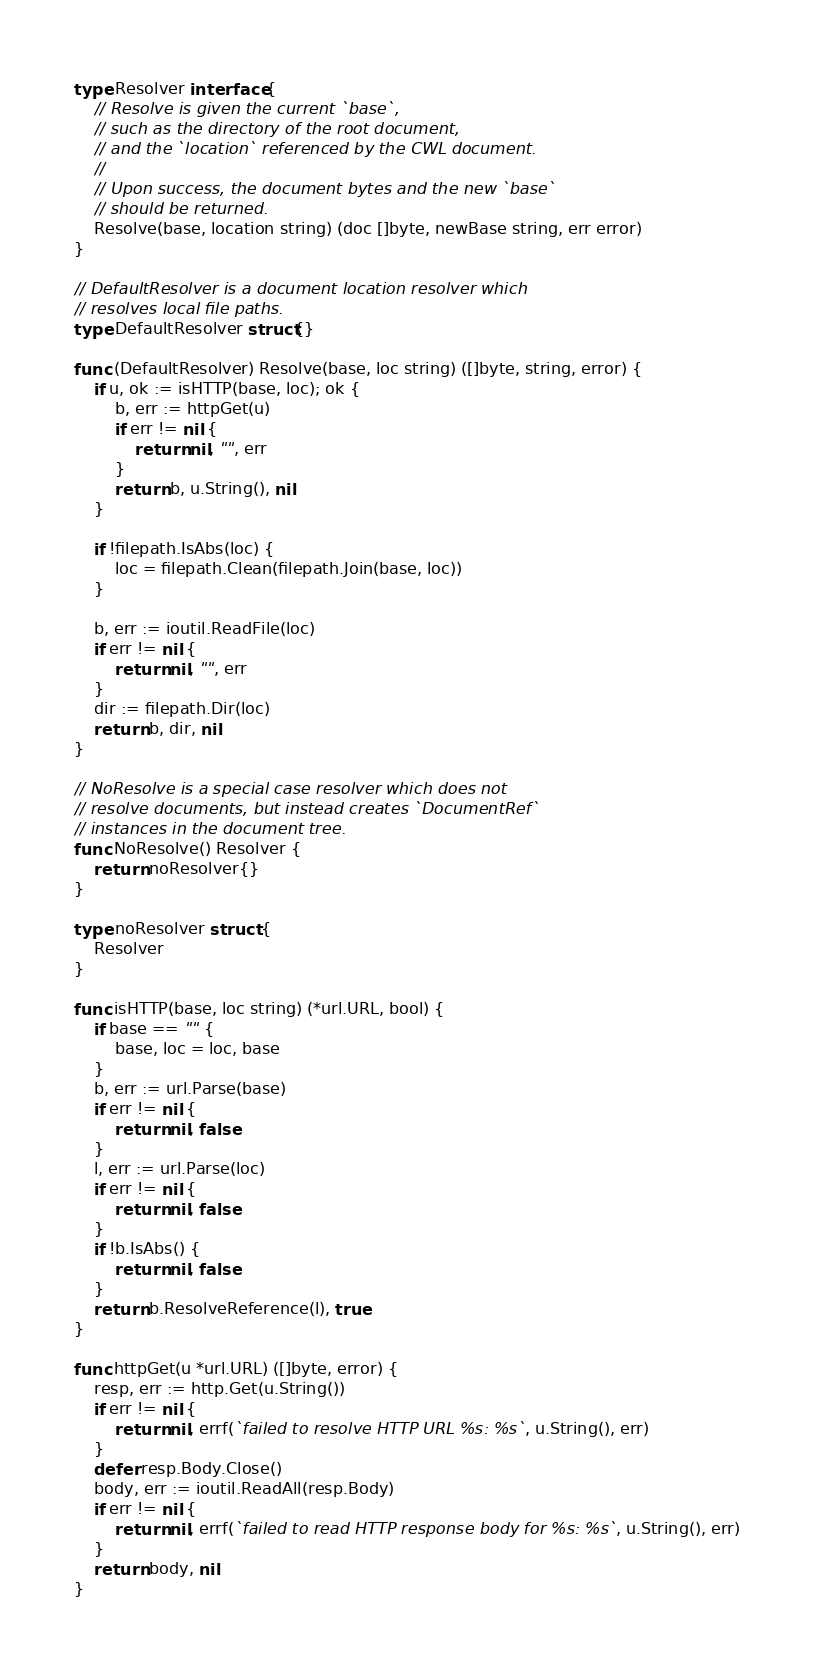<code> <loc_0><loc_0><loc_500><loc_500><_Go_>type Resolver interface {
	// Resolve is given the current `base`,
	// such as the directory of the root document,
	// and the `location` referenced by the CWL document.
	//
	// Upon success, the document bytes and the new `base`
	// should be returned.
	Resolve(base, location string) (doc []byte, newBase string, err error)
}

// DefaultResolver is a document location resolver which
// resolves local file paths.
type DefaultResolver struct{}

func (DefaultResolver) Resolve(base, loc string) ([]byte, string, error) {
	if u, ok := isHTTP(base, loc); ok {
		b, err := httpGet(u)
		if err != nil {
			return nil, "", err
		}
		return b, u.String(), nil
	}

	if !filepath.IsAbs(loc) {
		loc = filepath.Clean(filepath.Join(base, loc))
	}

	b, err := ioutil.ReadFile(loc)
	if err != nil {
		return nil, "", err
	}
	dir := filepath.Dir(loc)
	return b, dir, nil
}

// NoResolve is a special case resolver which does not
// resolve documents, but instead creates `DocumentRef`
// instances in the document tree.
func NoResolve() Resolver {
	return noResolver{}
}

type noResolver struct {
	Resolver
}

func isHTTP(base, loc string) (*url.URL, bool) {
	if base == "" {
		base, loc = loc, base
	}
	b, err := url.Parse(base)
	if err != nil {
		return nil, false
	}
	l, err := url.Parse(loc)
	if err != nil {
		return nil, false
	}
	if !b.IsAbs() {
		return nil, false
	}
	return b.ResolveReference(l), true
}

func httpGet(u *url.URL) ([]byte, error) {
	resp, err := http.Get(u.String())
	if err != nil {
		return nil, errf(`failed to resolve HTTP URL %s: %s`, u.String(), err)
	}
	defer resp.Body.Close()
	body, err := ioutil.ReadAll(resp.Body)
	if err != nil {
		return nil, errf(`failed to read HTTP response body for %s: %s`, u.String(), err)
	}
	return body, nil
}
</code> 